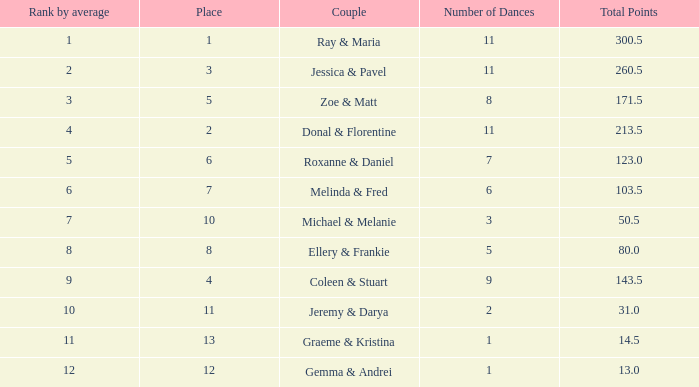If the combined points amount to 5 1.0. 